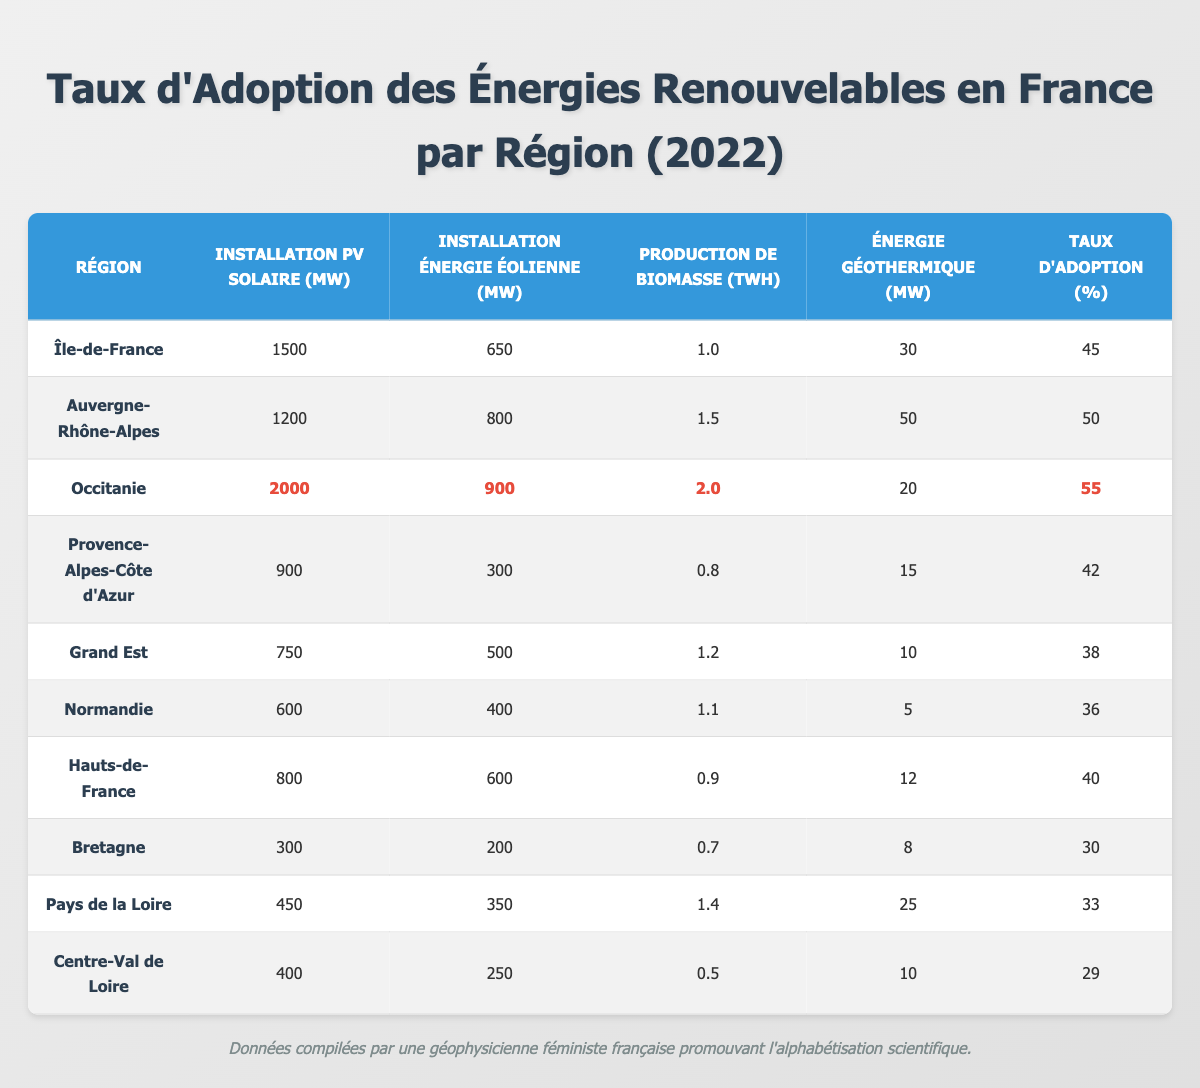What is the adoption rate percentage for the Occitanie region? The table shows that the adoption rate percentage for Occitanie is listed in the last column, which is highlighted. The value is 55%.
Answer: 55% Which region has the highest Solar PV installation? Looking at the Solar PV installation column, Occitanie has the highest value at 2000 MW.
Answer: Occitanie What is the total Wind Energy installation in Auvergne-Rhône-Alpes and Occitanie combined? Auvergne-Rhône-Alpes has 800 MW and Occitanie has 900 MW. Adding them together gives 800 + 900 = 1700 MW.
Answer: 1700 MW True or False: Bretagne has more Solar PV installation than Hauts-de-France. The Solar PV installation for Bretagne is 300 MW and for Hauts-de-France it is 800 MW. Since 300 is less than 800, the statement is false.
Answer: False What is the average adoption rate percentage for regions with more than 1000 MW of Solar PV installation? The regions with more than 1000 MW of Solar PV installation are Île-de-France, Auvergne-Rhône-Alpes, and Occitanie, with rates of 45%, 50%, and 55% respectively. The average is (45 + 50 + 55) / 3 = 50%.
Answer: 50% Which region has the least adoption rate percentage? The table indicates that the region with the least adoption rate percentage is Centre-Val de Loire, with a value of 29%.
Answer: Centre-Val de Loire How many regions have an adoption rate percentage of 40% or higher? The regions with an adoption rate of 40% or higher are Île-de-France (45%), Auvergne-Rhône-Alpes (50%), Occitanie (55%), and Hauts-de-France (40%). Thus, there are 4 regions.
Answer: 4 If we compare the total biomass production of Grand Est and Normandie, which region has more and by how much? Grand Est has 1.2 TWh of biomass production while Normandie has 1.1 TWh. The difference is 1.2 - 1.1 = 0.1 TWh, so Grand Est has more.
Answer: Grand Est; 0.1 TWh more Which region has the highest geothermal energy installation? Observing the values in the geothermal energy column, Auvergne-Rhône-Alpes has the highest at 50 MW.
Answer: Auvergne-Rhône-Alpes What percentage of total Renewable Energy Adoption rates corresponds to the lowest three regions? The three regions with the lowest adoption rates are Bretagne (30%), Pays de la Loire (33%), and Centre-Val de Loire (29%). Adding these gives 30 + 33 + 29 = 92%. Then, calculating the average gives 92 / 3 = 30.67%.
Answer: 30.67% 